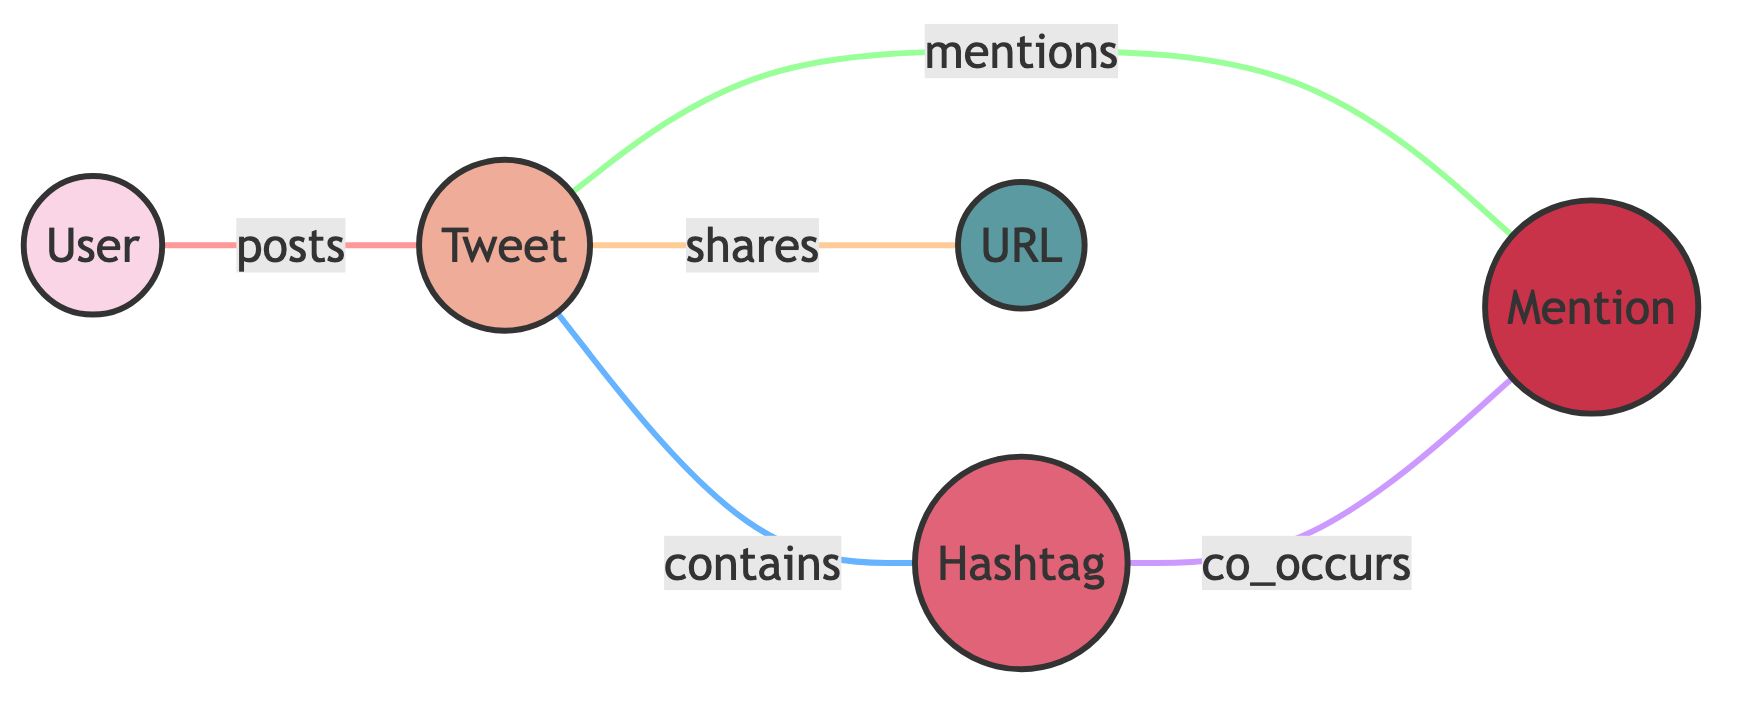What is the total number of nodes in the graph? To find the total number of nodes, we count each unique node in the diagram. The nodes are: User, Tweet, Hashtag, Mention, and URL, totaling five nodes.
Answer: 5 What is the label of node 3? Node 3 corresponds to a Hashtag, as indicated by the label associated with this node in the diagram.
Answer: Hashtag Which node is connected to the Tweet node through the "mentions" edge? The "mentions" edge is drawn from the Tweet node (2) to the Mention node (4) in the diagram, showing this direct connection.
Answer: Mention What type of relationship exists between the User and Tweet nodes? The edge labeled "posts" indicates the direct relationship between User (1) and Tweet (2), defining the interaction where a user posts a tweet.
Answer: posts How many edges are connected to the Tweet node? By counting the edges originating or terminating at the Tweet node (2), we find it is connected by four edges: "posts," "contains," "mentions," and "shares."
Answer: 4 Which two nodes co-occur based on the diagram? The edge labeled "co_occurs" connects the Hashtag (3) and Mention (4) nodes, indicating that these two nodes co-occur with each other significantly.
Answer: Hashtag and Mention From the Tweet node, which node does it share a direct connection with labeled "shares"? The edge from the Tweet node (2) labeled "shares" connects to the URL node (5), demonstrating a direct relationship in the graph.
Answer: URL What is the relationship between the Hashtag and Mention nodes? The edge between Hashtag (3) and Mention (4) is labeled "co_occurs," which describes their relationship in the context of the graph.
Answer: co_occurs How many distinct relationships can be identified from the Tweet node? Totaling the relationships found in the edges from the Tweet (2) node—contains, mentions, and shares—leads to a count of three distinct relationships.
Answer: 3 